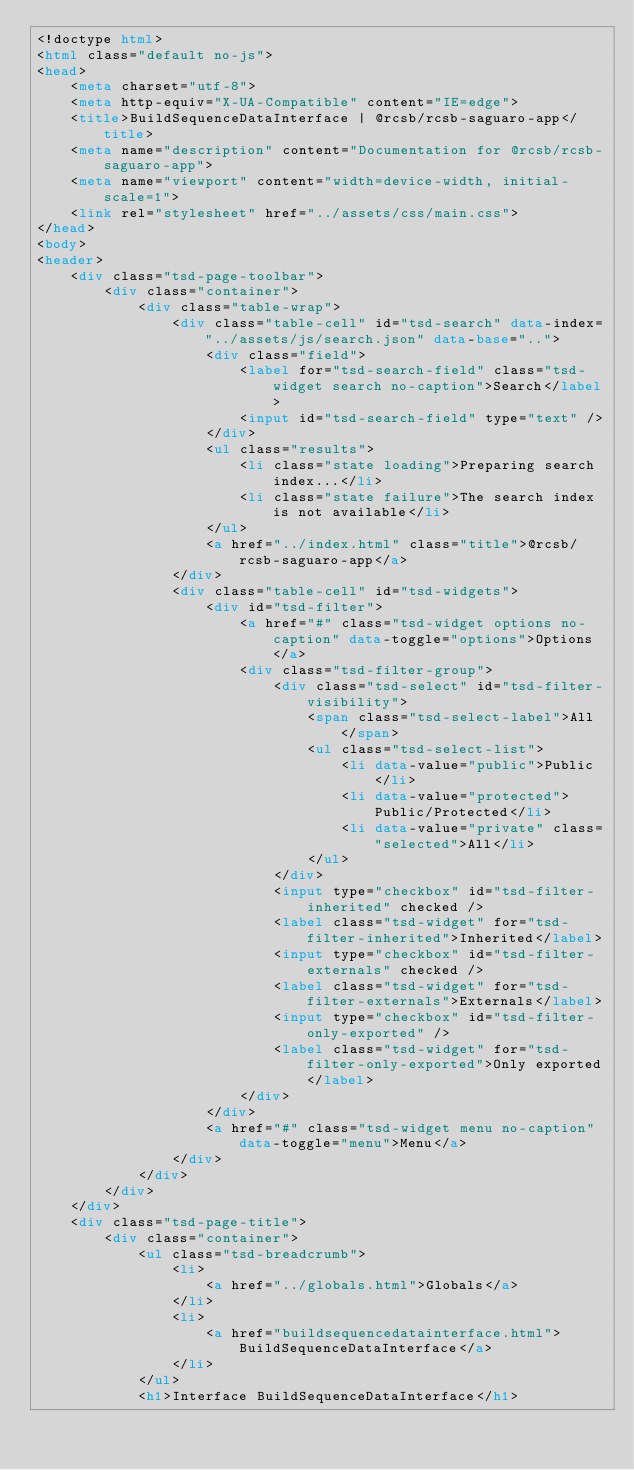<code> <loc_0><loc_0><loc_500><loc_500><_HTML_><!doctype html>
<html class="default no-js">
<head>
	<meta charset="utf-8">
	<meta http-equiv="X-UA-Compatible" content="IE=edge">
	<title>BuildSequenceDataInterface | @rcsb/rcsb-saguaro-app</title>
	<meta name="description" content="Documentation for @rcsb/rcsb-saguaro-app">
	<meta name="viewport" content="width=device-width, initial-scale=1">
	<link rel="stylesheet" href="../assets/css/main.css">
</head>
<body>
<header>
	<div class="tsd-page-toolbar">
		<div class="container">
			<div class="table-wrap">
				<div class="table-cell" id="tsd-search" data-index="../assets/js/search.json" data-base="..">
					<div class="field">
						<label for="tsd-search-field" class="tsd-widget search no-caption">Search</label>
						<input id="tsd-search-field" type="text" />
					</div>
					<ul class="results">
						<li class="state loading">Preparing search index...</li>
						<li class="state failure">The search index is not available</li>
					</ul>
					<a href="../index.html" class="title">@rcsb/rcsb-saguaro-app</a>
				</div>
				<div class="table-cell" id="tsd-widgets">
					<div id="tsd-filter">
						<a href="#" class="tsd-widget options no-caption" data-toggle="options">Options</a>
						<div class="tsd-filter-group">
							<div class="tsd-select" id="tsd-filter-visibility">
								<span class="tsd-select-label">All</span>
								<ul class="tsd-select-list">
									<li data-value="public">Public</li>
									<li data-value="protected">Public/Protected</li>
									<li data-value="private" class="selected">All</li>
								</ul>
							</div>
							<input type="checkbox" id="tsd-filter-inherited" checked />
							<label class="tsd-widget" for="tsd-filter-inherited">Inherited</label>
							<input type="checkbox" id="tsd-filter-externals" checked />
							<label class="tsd-widget" for="tsd-filter-externals">Externals</label>
							<input type="checkbox" id="tsd-filter-only-exported" />
							<label class="tsd-widget" for="tsd-filter-only-exported">Only exported</label>
						</div>
					</div>
					<a href="#" class="tsd-widget menu no-caption" data-toggle="menu">Menu</a>
				</div>
			</div>
		</div>
	</div>
	<div class="tsd-page-title">
		<div class="container">
			<ul class="tsd-breadcrumb">
				<li>
					<a href="../globals.html">Globals</a>
				</li>
				<li>
					<a href="buildsequencedatainterface.html">BuildSequenceDataInterface</a>
				</li>
			</ul>
			<h1>Interface BuildSequenceDataInterface</h1></code> 